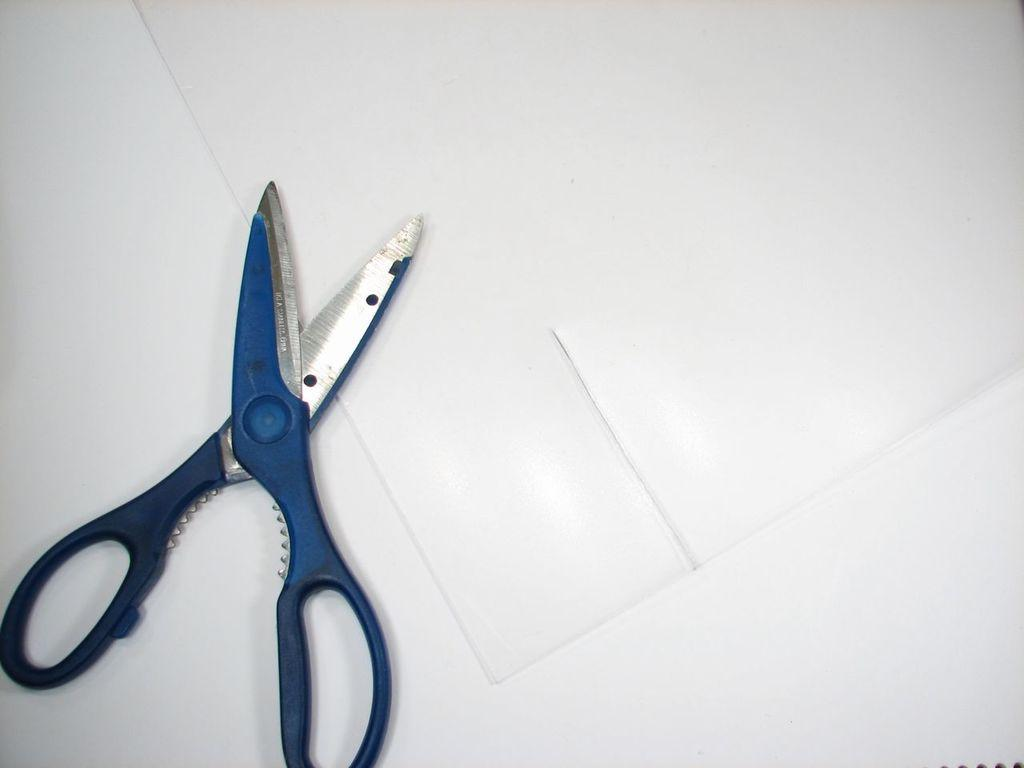What object is used for cutting in the image? There are scissors in the image. What material is being cut or worked with in the image? There is paper in the image. Where are the scissors and paper located in the image? The scissors and paper are placed on a table. What type of minister is depicted in the image? There is no minister present in the image; it features scissors and paper on a table. Can you provide an example of a vase in the image? There is no vase present in the image. 